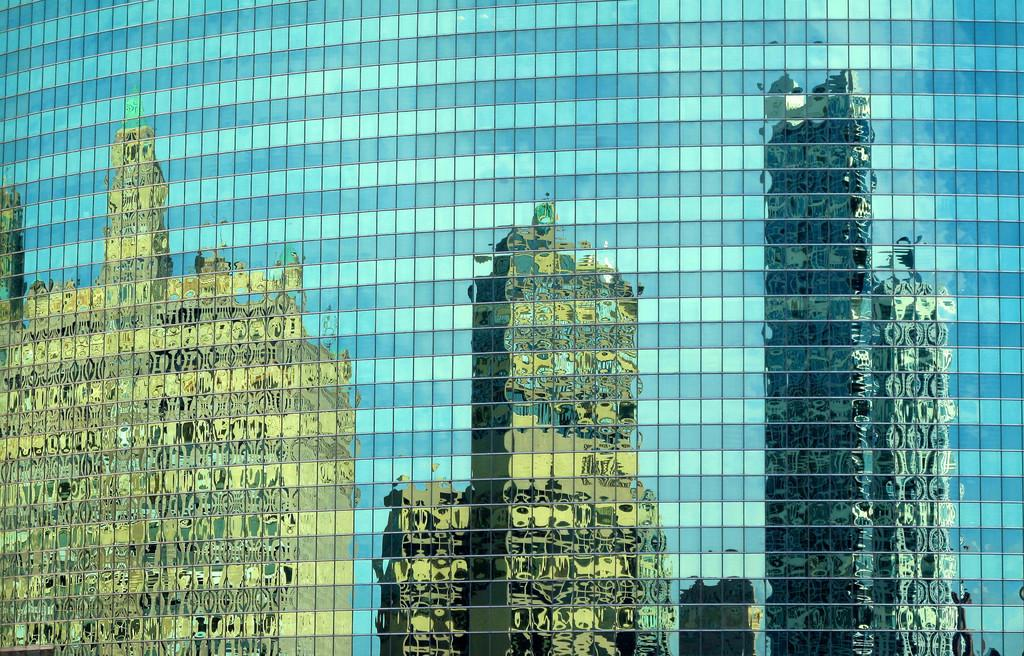What is the main subject of the image? The main subject of the image is a building. Are there any notable features of the building? Yes, the building has reflections of other buildings on it. How many owls can be seen sitting on the roof of the building in the image? There are no owls present on the roof of the building in the image. What type of game is being played on the roof of the building in the image? There is no game being played on the roof of the building in the image. 